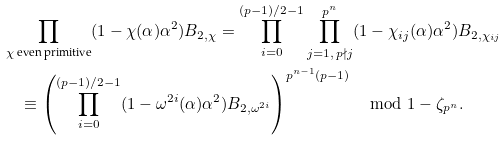Convert formula to latex. <formula><loc_0><loc_0><loc_500><loc_500>& \prod _ { \chi \text { even primitive} } ( 1 - \chi ( \alpha ) \alpha ^ { 2 } ) B _ { 2 , \chi } = \prod _ { i = 0 } ^ { ( p - 1 ) / 2 - 1 } \prod _ { j = 1 , \, p \nmid j } ^ { p ^ { n } } ( 1 - \chi _ { i j } ( \alpha ) \alpha ^ { 2 } ) B _ { 2 , \chi _ { i j } } \\ & \quad \equiv \left ( \prod _ { i = 0 } ^ { ( p - 1 ) / 2 - 1 } ( 1 - \omega ^ { 2 i } ( \alpha ) \alpha ^ { 2 } ) B _ { 2 , \omega ^ { 2 i } } \right ) ^ { p ^ { n - 1 } ( p - 1 ) } \mod 1 - \zeta _ { p ^ { n } } .</formula> 